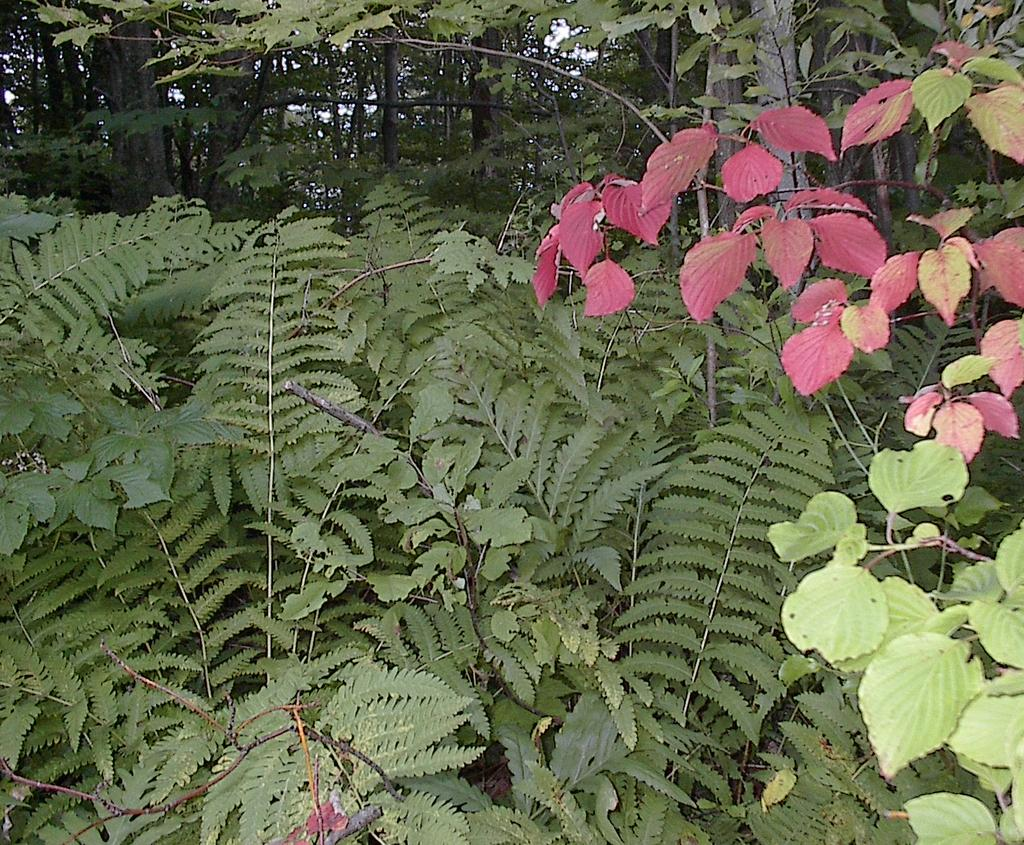What type of vegetation can be seen in the image? There are trees in the image. What type of fruit is hanging from the trees in the image? There is no fruit visible in the image; only trees are present. Is there a flag flying among the trees in the image? There is no flag present in the image; only trees are visible. 